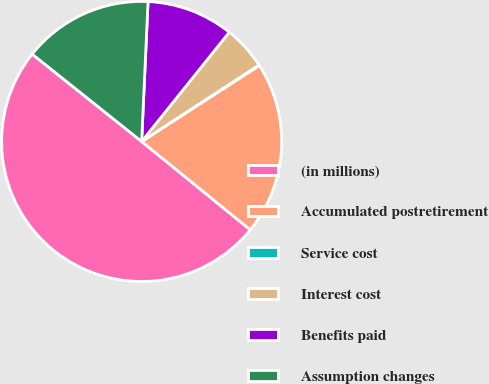<chart> <loc_0><loc_0><loc_500><loc_500><pie_chart><fcel>(in millions)<fcel>Accumulated postretirement<fcel>Service cost<fcel>Interest cost<fcel>Benefits paid<fcel>Assumption changes<nl><fcel>49.85%<fcel>19.99%<fcel>0.07%<fcel>5.05%<fcel>10.03%<fcel>15.01%<nl></chart> 